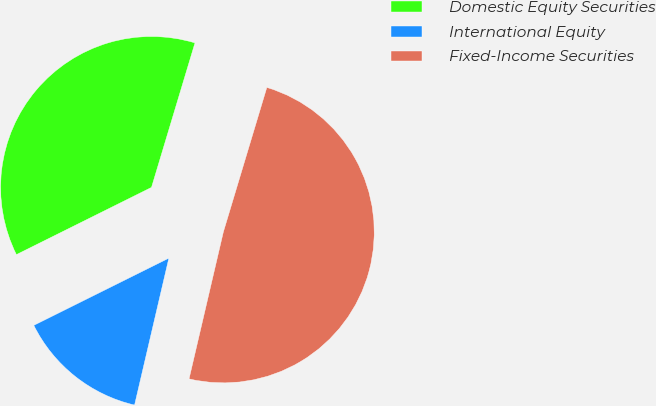Convert chart to OTSL. <chart><loc_0><loc_0><loc_500><loc_500><pie_chart><fcel>Domestic Equity Securities<fcel>International Equity<fcel>Fixed-Income Securities<nl><fcel>37.0%<fcel>14.0%<fcel>49.0%<nl></chart> 